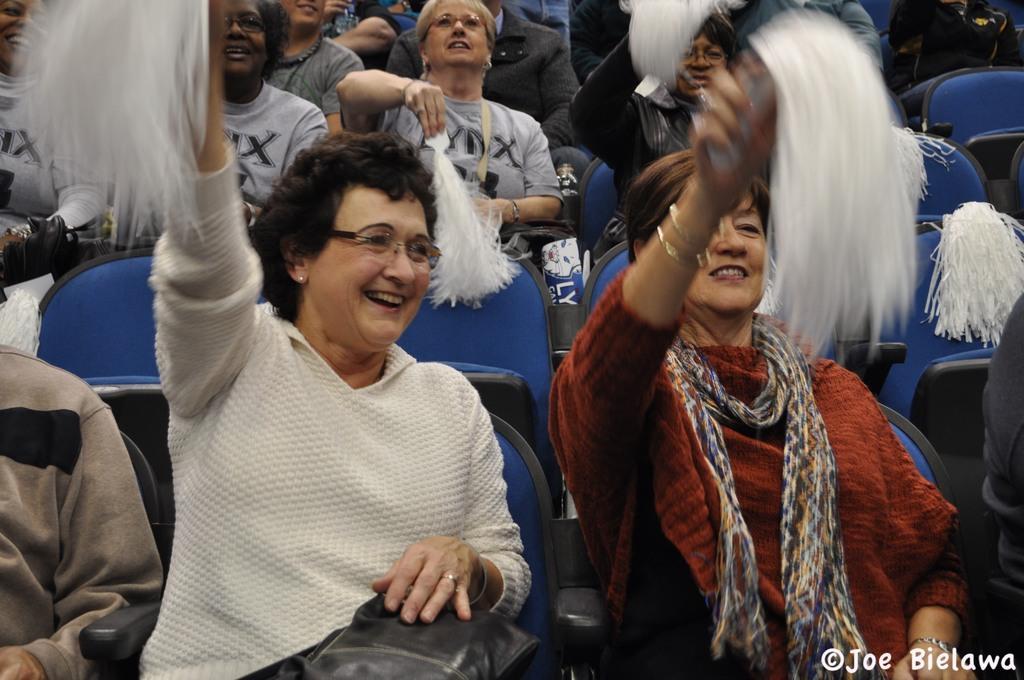Describe this image in one or two sentences. In this image we can see people sitting on the chairs and holding pom poms in their hands. 